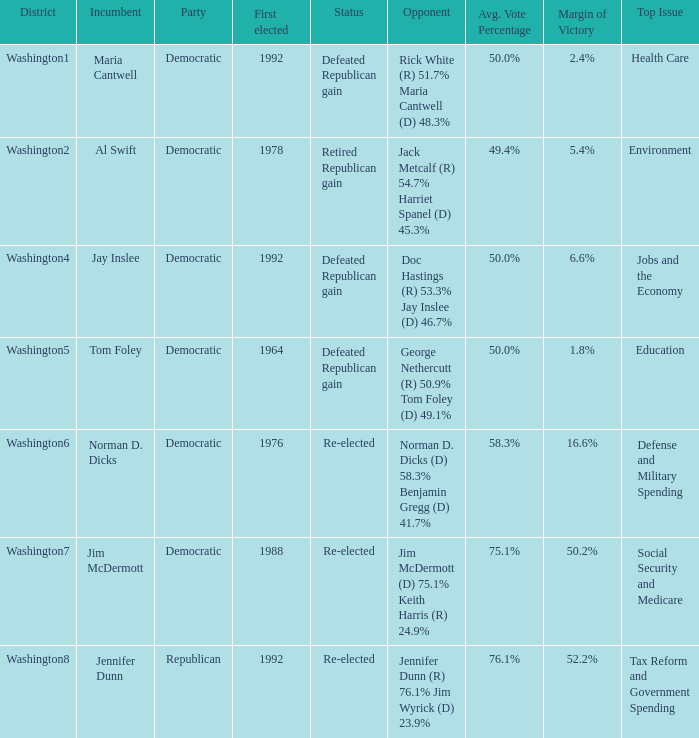What was the result of the election of doc hastings (r) 53.3% jay inslee (d) 46.7% Defeated Republican gain. 